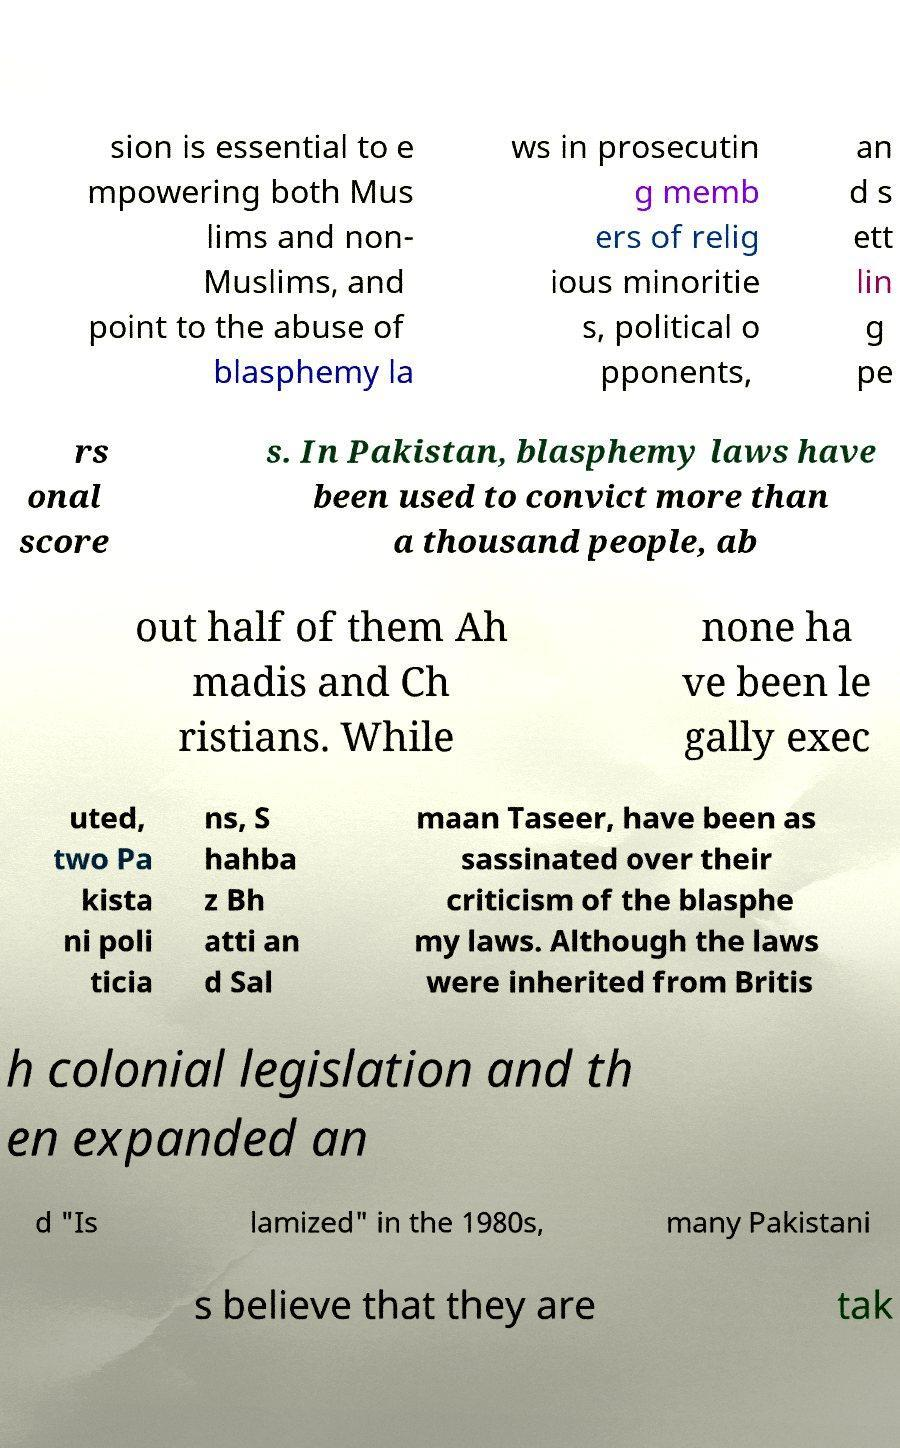Please identify and transcribe the text found in this image. sion is essential to e mpowering both Mus lims and non- Muslims, and point to the abuse of blasphemy la ws in prosecutin g memb ers of relig ious minoritie s, political o pponents, an d s ett lin g pe rs onal score s. In Pakistan, blasphemy laws have been used to convict more than a thousand people, ab out half of them Ah madis and Ch ristians. While none ha ve been le gally exec uted, two Pa kista ni poli ticia ns, S hahba z Bh atti an d Sal maan Taseer, have been as sassinated over their criticism of the blasphe my laws. Although the laws were inherited from Britis h colonial legislation and th en expanded an d "Is lamized" in the 1980s, many Pakistani s believe that they are tak 